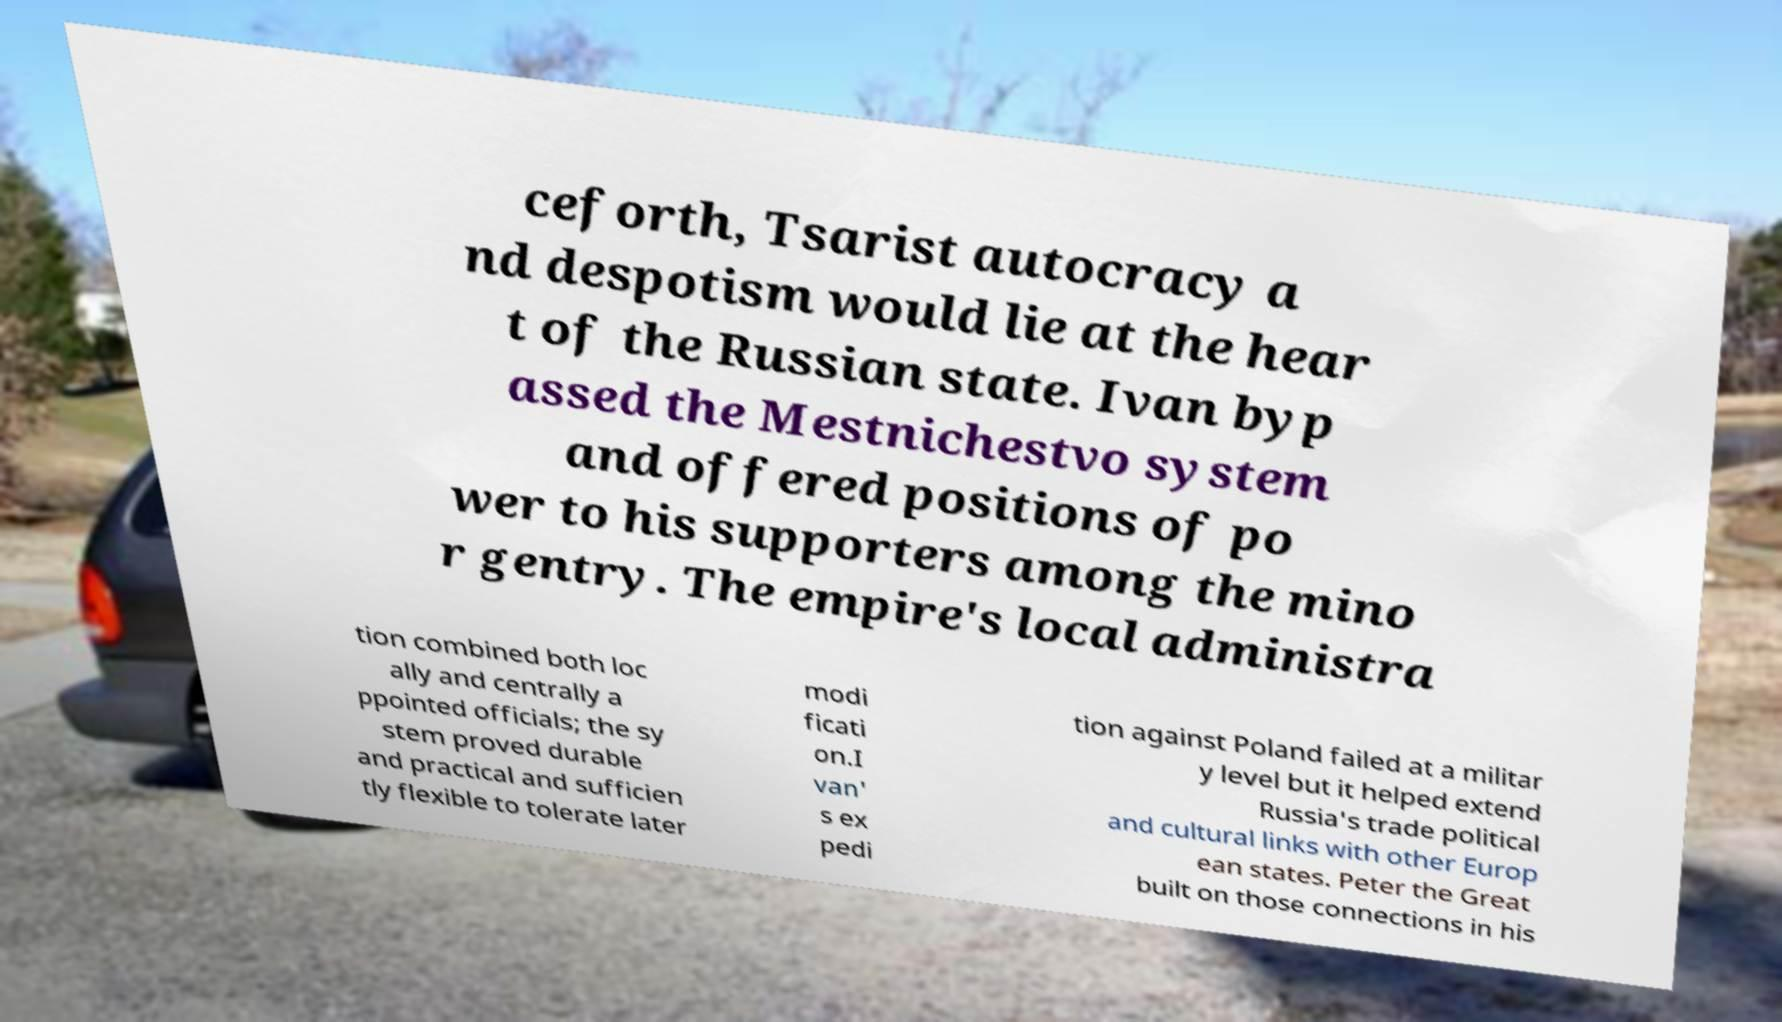Please read and relay the text visible in this image. What does it say? ceforth, Tsarist autocracy a nd despotism would lie at the hear t of the Russian state. Ivan byp assed the Mestnichestvo system and offered positions of po wer to his supporters among the mino r gentry. The empire's local administra tion combined both loc ally and centrally a ppointed officials; the sy stem proved durable and practical and sufficien tly flexible to tolerate later modi ficati on.I van' s ex pedi tion against Poland failed at a militar y level but it helped extend Russia's trade political and cultural links with other Europ ean states. Peter the Great built on those connections in his 